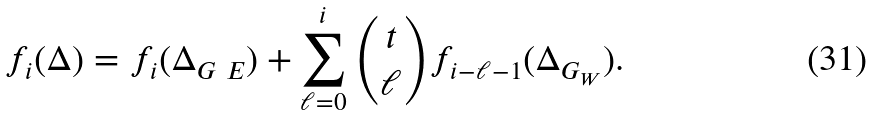<formula> <loc_0><loc_0><loc_500><loc_500>f _ { i } ( \Delta ) = f _ { i } ( { \Delta } _ { G \ E } ) + \sum _ { \ell = 0 } ^ { i } \binom { t } { \ell } f _ { i - \ell - 1 } ( { \Delta } _ { G _ { W } } ) .</formula> 